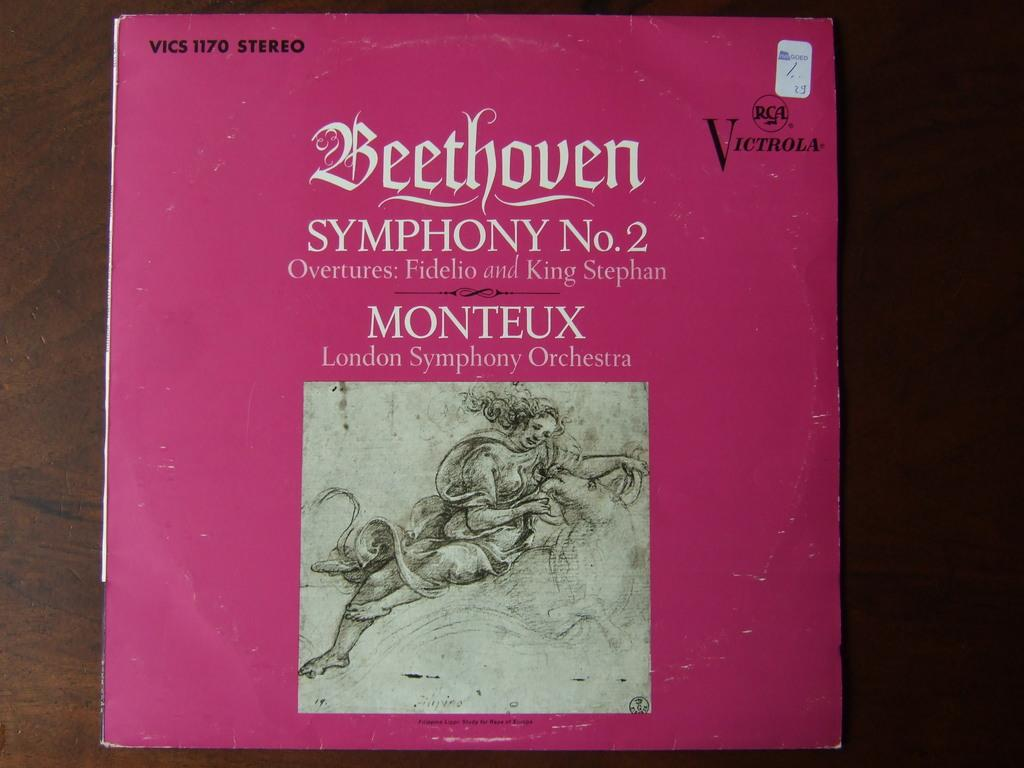Provide a one-sentence caption for the provided image. The Victrola record cover sleeve of Beethoven's Symphony No 2. 